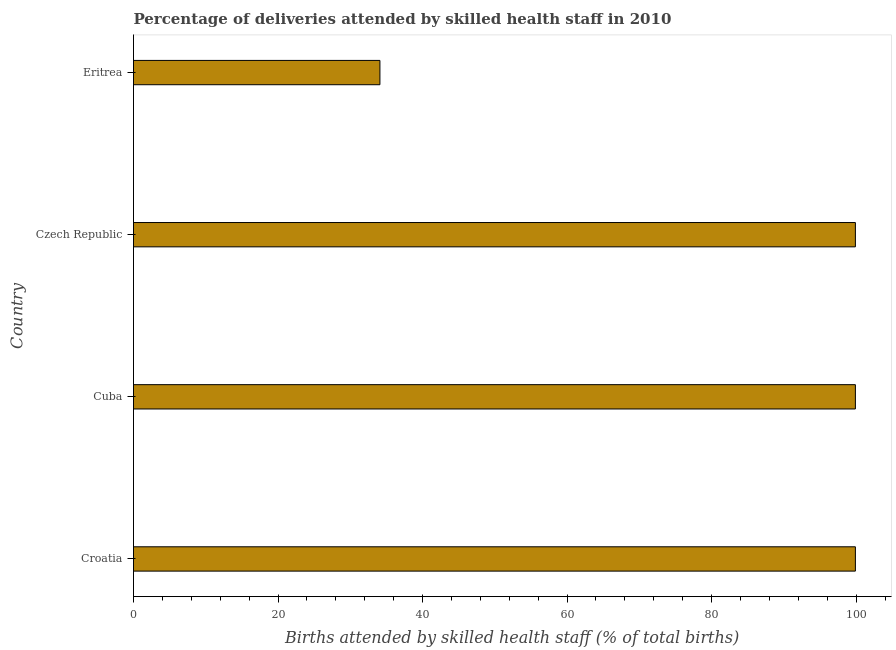Does the graph contain grids?
Make the answer very short. No. What is the title of the graph?
Give a very brief answer. Percentage of deliveries attended by skilled health staff in 2010. What is the label or title of the X-axis?
Make the answer very short. Births attended by skilled health staff (% of total births). What is the number of births attended by skilled health staff in Czech Republic?
Provide a short and direct response. 99.9. Across all countries, what is the maximum number of births attended by skilled health staff?
Keep it short and to the point. 99.9. Across all countries, what is the minimum number of births attended by skilled health staff?
Your answer should be compact. 34.1. In which country was the number of births attended by skilled health staff maximum?
Your response must be concise. Croatia. In which country was the number of births attended by skilled health staff minimum?
Your answer should be compact. Eritrea. What is the sum of the number of births attended by skilled health staff?
Your answer should be compact. 333.8. What is the difference between the number of births attended by skilled health staff in Czech Republic and Eritrea?
Your answer should be compact. 65.8. What is the average number of births attended by skilled health staff per country?
Your answer should be compact. 83.45. What is the median number of births attended by skilled health staff?
Give a very brief answer. 99.9. In how many countries, is the number of births attended by skilled health staff greater than 28 %?
Your response must be concise. 4. Is the number of births attended by skilled health staff in Cuba less than that in Eritrea?
Keep it short and to the point. No. Is the difference between the number of births attended by skilled health staff in Croatia and Eritrea greater than the difference between any two countries?
Make the answer very short. Yes. Is the sum of the number of births attended by skilled health staff in Czech Republic and Eritrea greater than the maximum number of births attended by skilled health staff across all countries?
Your answer should be very brief. Yes. What is the difference between the highest and the lowest number of births attended by skilled health staff?
Provide a short and direct response. 65.8. In how many countries, is the number of births attended by skilled health staff greater than the average number of births attended by skilled health staff taken over all countries?
Ensure brevity in your answer.  3. What is the difference between two consecutive major ticks on the X-axis?
Offer a very short reply. 20. What is the Births attended by skilled health staff (% of total births) of Croatia?
Give a very brief answer. 99.9. What is the Births attended by skilled health staff (% of total births) of Cuba?
Offer a terse response. 99.9. What is the Births attended by skilled health staff (% of total births) of Czech Republic?
Keep it short and to the point. 99.9. What is the Births attended by skilled health staff (% of total births) of Eritrea?
Provide a succinct answer. 34.1. What is the difference between the Births attended by skilled health staff (% of total births) in Croatia and Cuba?
Provide a short and direct response. 0. What is the difference between the Births attended by skilled health staff (% of total births) in Croatia and Czech Republic?
Your answer should be very brief. 0. What is the difference between the Births attended by skilled health staff (% of total births) in Croatia and Eritrea?
Your response must be concise. 65.8. What is the difference between the Births attended by skilled health staff (% of total births) in Cuba and Eritrea?
Offer a terse response. 65.8. What is the difference between the Births attended by skilled health staff (% of total births) in Czech Republic and Eritrea?
Provide a succinct answer. 65.8. What is the ratio of the Births attended by skilled health staff (% of total births) in Croatia to that in Eritrea?
Provide a succinct answer. 2.93. What is the ratio of the Births attended by skilled health staff (% of total births) in Cuba to that in Eritrea?
Your response must be concise. 2.93. What is the ratio of the Births attended by skilled health staff (% of total births) in Czech Republic to that in Eritrea?
Give a very brief answer. 2.93. 